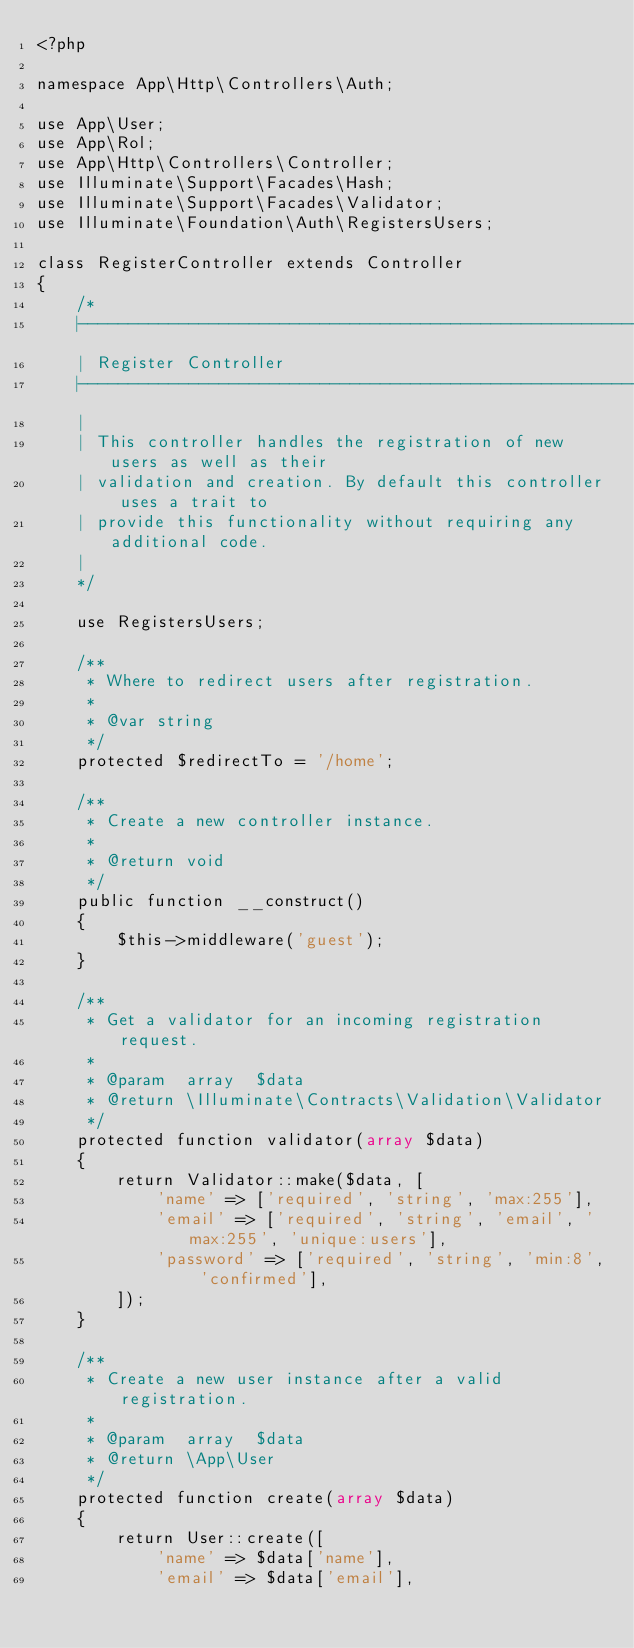<code> <loc_0><loc_0><loc_500><loc_500><_PHP_><?php

namespace App\Http\Controllers\Auth;

use App\User;
use App\Rol;
use App\Http\Controllers\Controller;
use Illuminate\Support\Facades\Hash;
use Illuminate\Support\Facades\Validator;
use Illuminate\Foundation\Auth\RegistersUsers;

class RegisterController extends Controller
{
    /*
    |--------------------------------------------------------------------------
    | Register Controller
    |--------------------------------------------------------------------------
    |
    | This controller handles the registration of new users as well as their
    | validation and creation. By default this controller uses a trait to
    | provide this functionality without requiring any additional code.
    |
    */

    use RegistersUsers;

    /**
     * Where to redirect users after registration.
     *
     * @var string
     */
    protected $redirectTo = '/home';

    /**
     * Create a new controller instance.
     *
     * @return void
     */
    public function __construct()
    {
        $this->middleware('guest');
    }

    /**
     * Get a validator for an incoming registration request.
     *
     * @param  array  $data
     * @return \Illuminate\Contracts\Validation\Validator
     */
    protected function validator(array $data)
    {
        return Validator::make($data, [
            'name' => ['required', 'string', 'max:255'],
            'email' => ['required', 'string', 'email', 'max:255', 'unique:users'],
            'password' => ['required', 'string', 'min:8', 'confirmed'],
        ]);
    }

    /**
     * Create a new user instance after a valid registration.
     *
     * @param  array  $data
     * @return \App\User
     */
    protected function create(array $data)
    {
        return User::create([
            'name' => $data['name'],
            'email' => $data['email'],</code> 